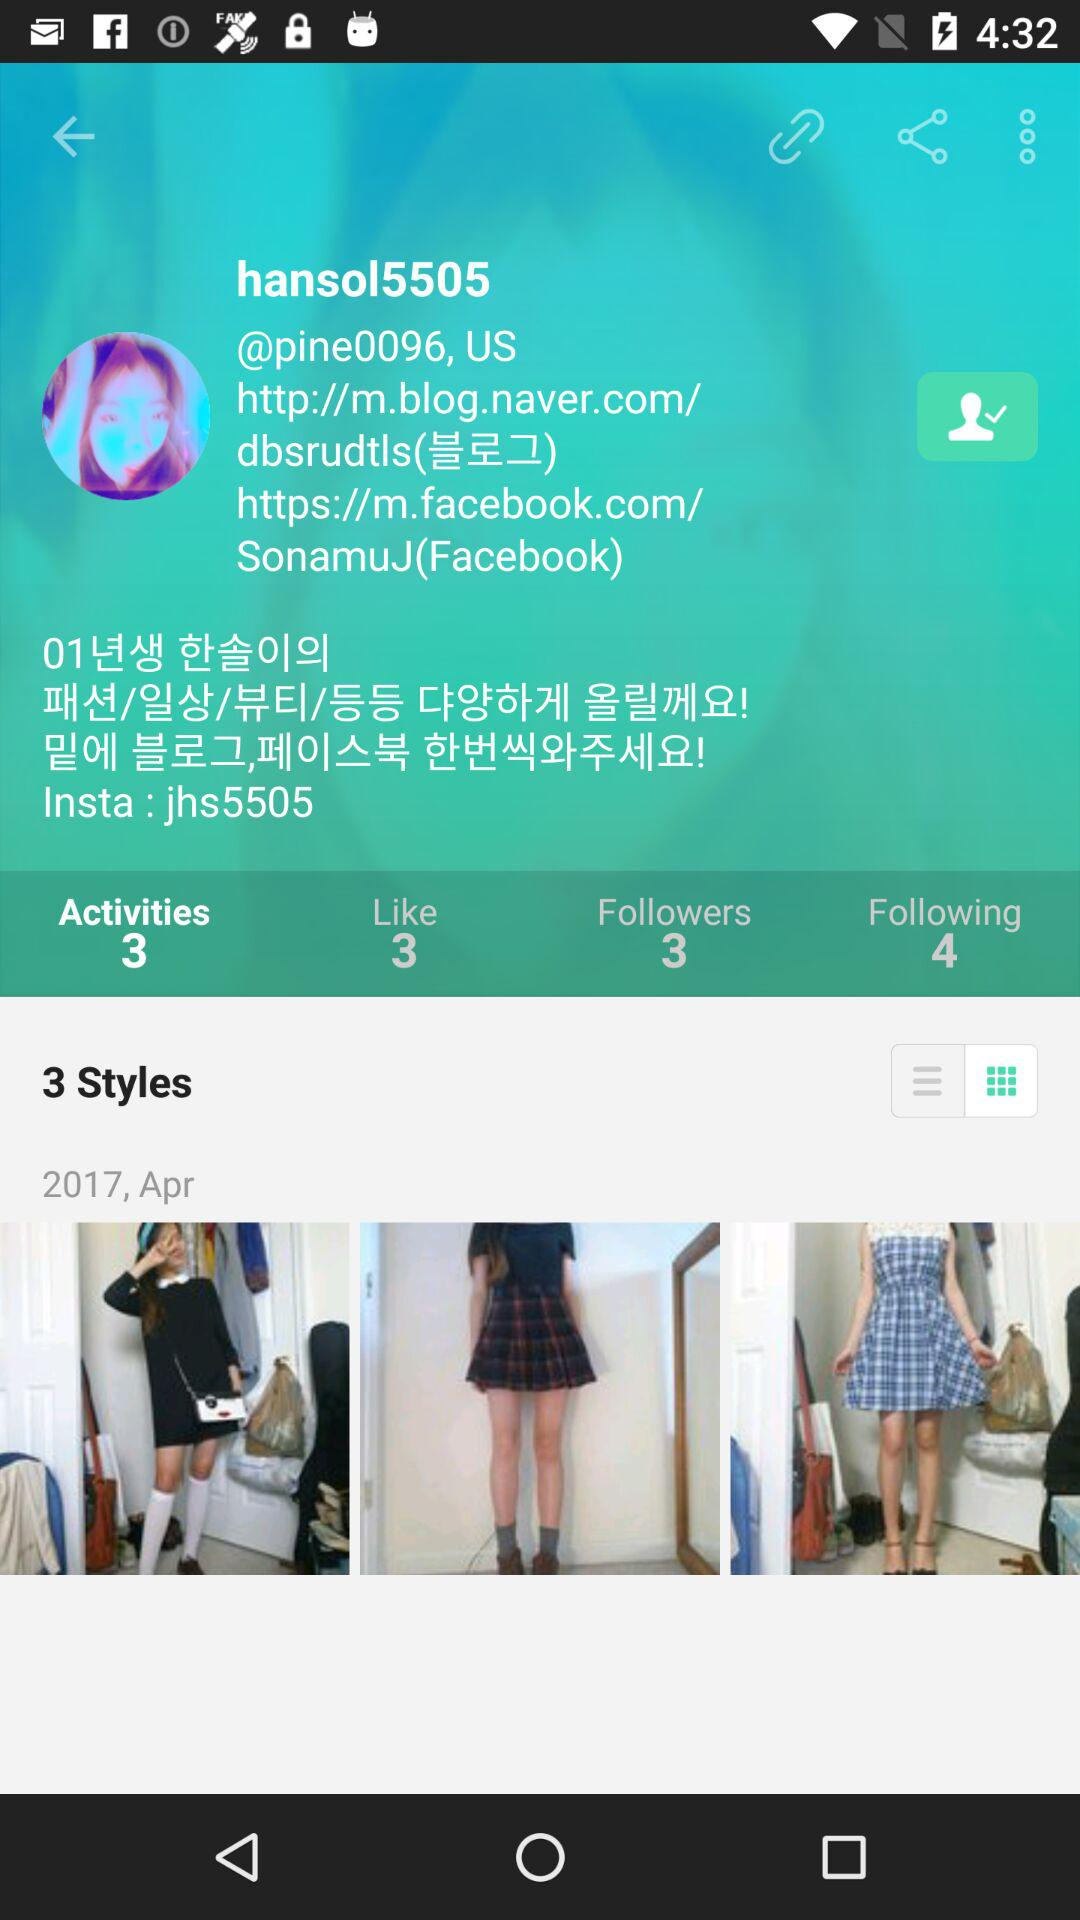What is the "Facebook" ID of the user? The "Facebook" ID of the user is SonamuJ. 